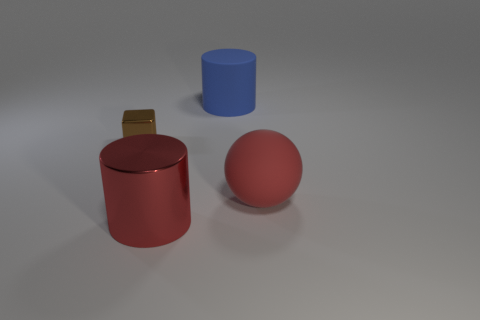Add 3 tiny blue matte blocks. How many objects exist? 7 Subtract 1 balls. How many balls are left? 0 Subtract all blue cylinders. How many cylinders are left? 1 Subtract all blocks. How many objects are left? 3 Subtract all purple blocks. How many green cylinders are left? 0 Add 2 yellow metal balls. How many yellow metal balls exist? 2 Subtract 0 gray spheres. How many objects are left? 4 Subtract all green balls. Subtract all cyan blocks. How many balls are left? 1 Subtract all big metallic cubes. Subtract all large red matte spheres. How many objects are left? 3 Add 2 big rubber things. How many big rubber things are left? 4 